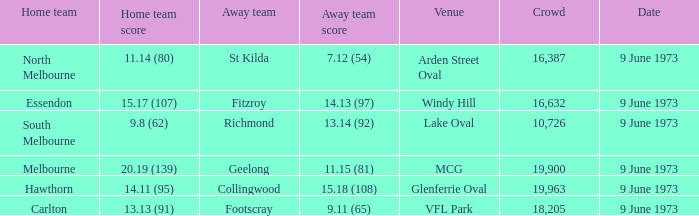At which location did fitzroy participate as the away team? Windy Hill. 